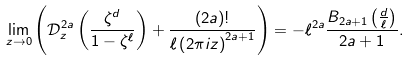Convert formula to latex. <formula><loc_0><loc_0><loc_500><loc_500>\lim _ { z \to 0 } \left ( \mathcal { D } _ { z } ^ { 2 a } \left ( \frac { \zeta ^ { d } } { 1 - \zeta ^ { \ell } } \right ) + \frac { ( 2 a ) ! } { \ell \left ( 2 \pi i z \right ) ^ { 2 a + 1 } } \right ) = - \ell ^ { 2 a } \frac { B _ { 2 a + 1 } \left ( \frac { d } { \ell } \right ) } { 2 a + 1 } .</formula> 